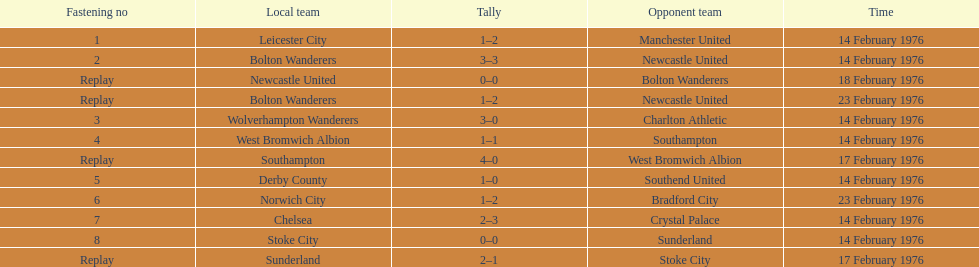How many contests did the bolton wanderers and newcastle united engage in before a definite champion was determined in the fifth round proper? 3. 